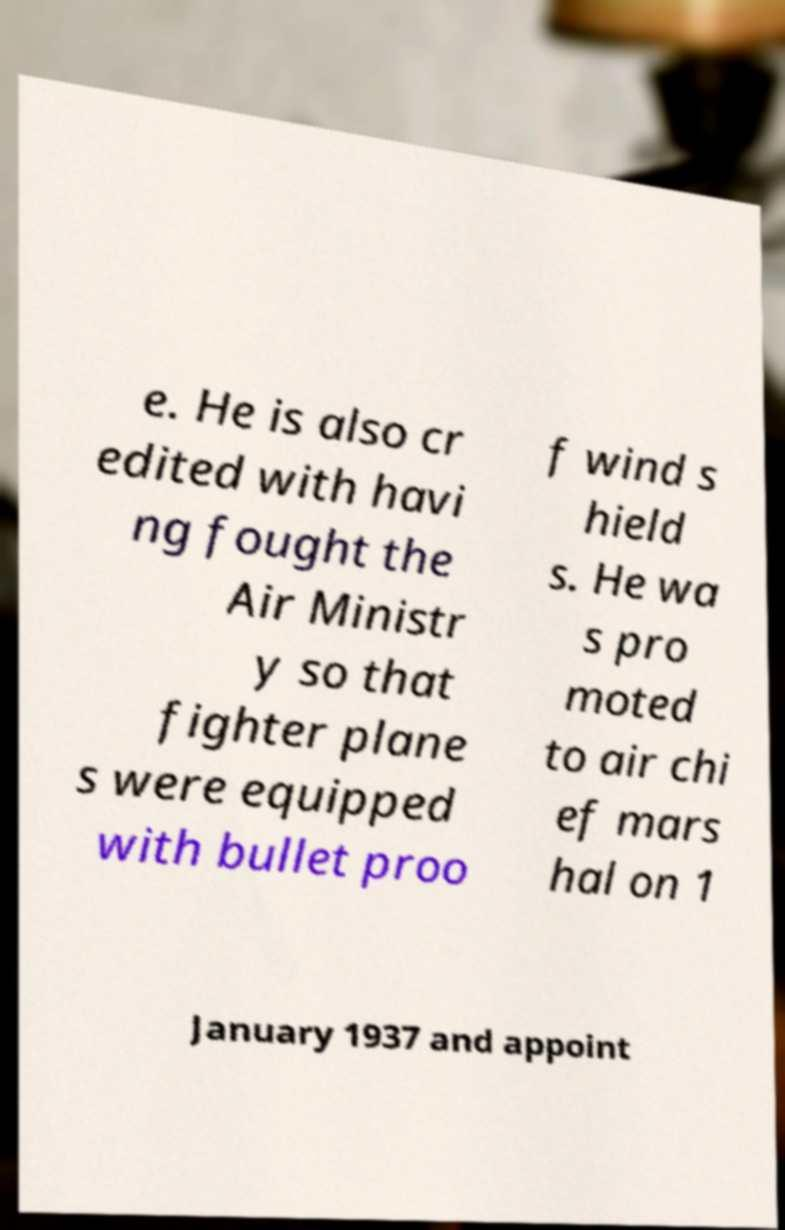I need the written content from this picture converted into text. Can you do that? e. He is also cr edited with havi ng fought the Air Ministr y so that fighter plane s were equipped with bullet proo f wind s hield s. He wa s pro moted to air chi ef mars hal on 1 January 1937 and appoint 